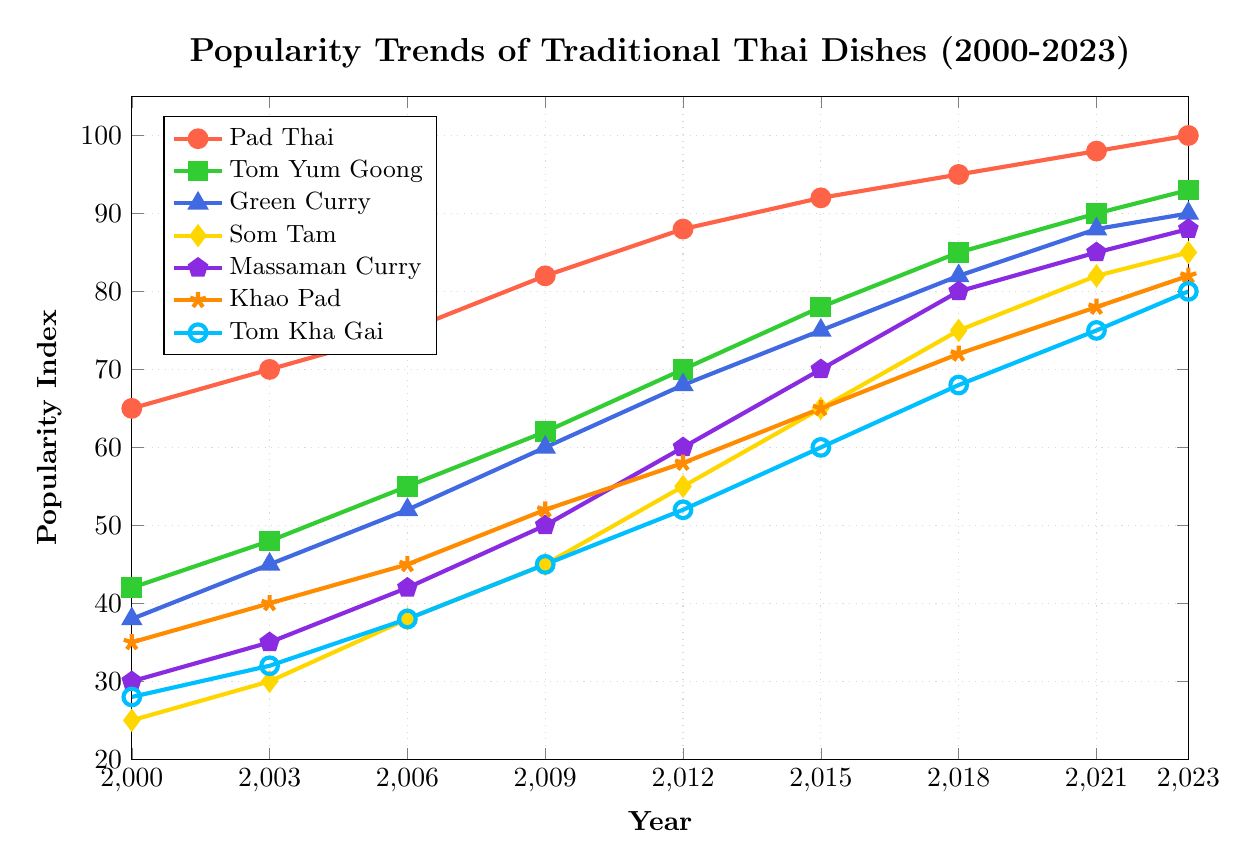What's the most popular traditional Thai dish in 2023? To determine the most popular traditional Thai dish in 2023, look at the data point for each dish in 2023 and identify the highest value. Pad Thai has a popularity index of 100, which is the highest of all dishes.
Answer: Pad Thai Which dish shows the greatest increase in popularity from 2000 to 2023? Calculate the difference in popularity index between 2000 and 2023 for each dish. Pad Thai increased from 65 to 100 (difference of 35), Tom Yum Goong from 42 to 93 (difference of 51), Green Curry from 38 to 90 (difference of 52), Som Tam from 25 to 85 (difference of 60), Massaman Curry from 30 to 88 (difference of 58), Khao Pad from 35 to 82 (difference of 47), Tom Kha Gai from 28 to 80 (difference of 52). Som Tam shows the greatest increase.
Answer: Som Tam Between 2009 and 2015, which dish had the smallest increase in popularity? Calculate the difference in popularity index between 2009 and 2015 for each dish: Pad Thai (92-82=10), Tom Yum Goong (78-62=16), Green Curry (75-60=15), Som Tam (65-45=20), Massaman Curry (70-50=20), Khao Pad (65-52=13), Tom Kha Gai (60-45=15). Pad Thai had the smallest increase.
Answer: Pad Thai Compare the popularity of Tom Yum Goong and Khao Pad in 2021. Which was more popular and by how much? In 2021, Tom Yum Goong has a popularity index of 90, while Khao Pad has 78. Therefore, Tom Yum Goong is more popular by (90-78=12).
Answer: Tom Yum Goong by 12 What is the average popularity index of Green Curry from 2000 to 2023? Calculate the sum of the popularity indices of Green Curry from 2000 to 2023 and divide by the number of years. Sum = 38+45+52+60+68+75+82+88+90 = 598; Number of years = 9. So, the average is 598/9 ≈ 66.44.
Answer: 66.44 Which dish had the slowest growth in popularity from 2018 to 2023? Calculate the difference in popularity index between 2018 and 2023 for each dish: Pad Thai (100-95=5), Tom Yum Goong (93-85=8), Green Curry (90-82=8), Som Tam (85-75=10), Massaman Curry (88-80=8), Khao Pad (82-72=10), Tom Kha Gai (80-68=12). Pad Thai had the slowest growth.
Answer: Pad Thai How does the popularity of Som Tam in 2012 compare to that of Green Curry in 2009? Look at the popularity indices: Som Tam in 2012 has 55, and Green Curry in 2009 has 60. Green Curry in 2009 was more popular by (60-55=5).
Answer: Green Curry in 2009 by 5 